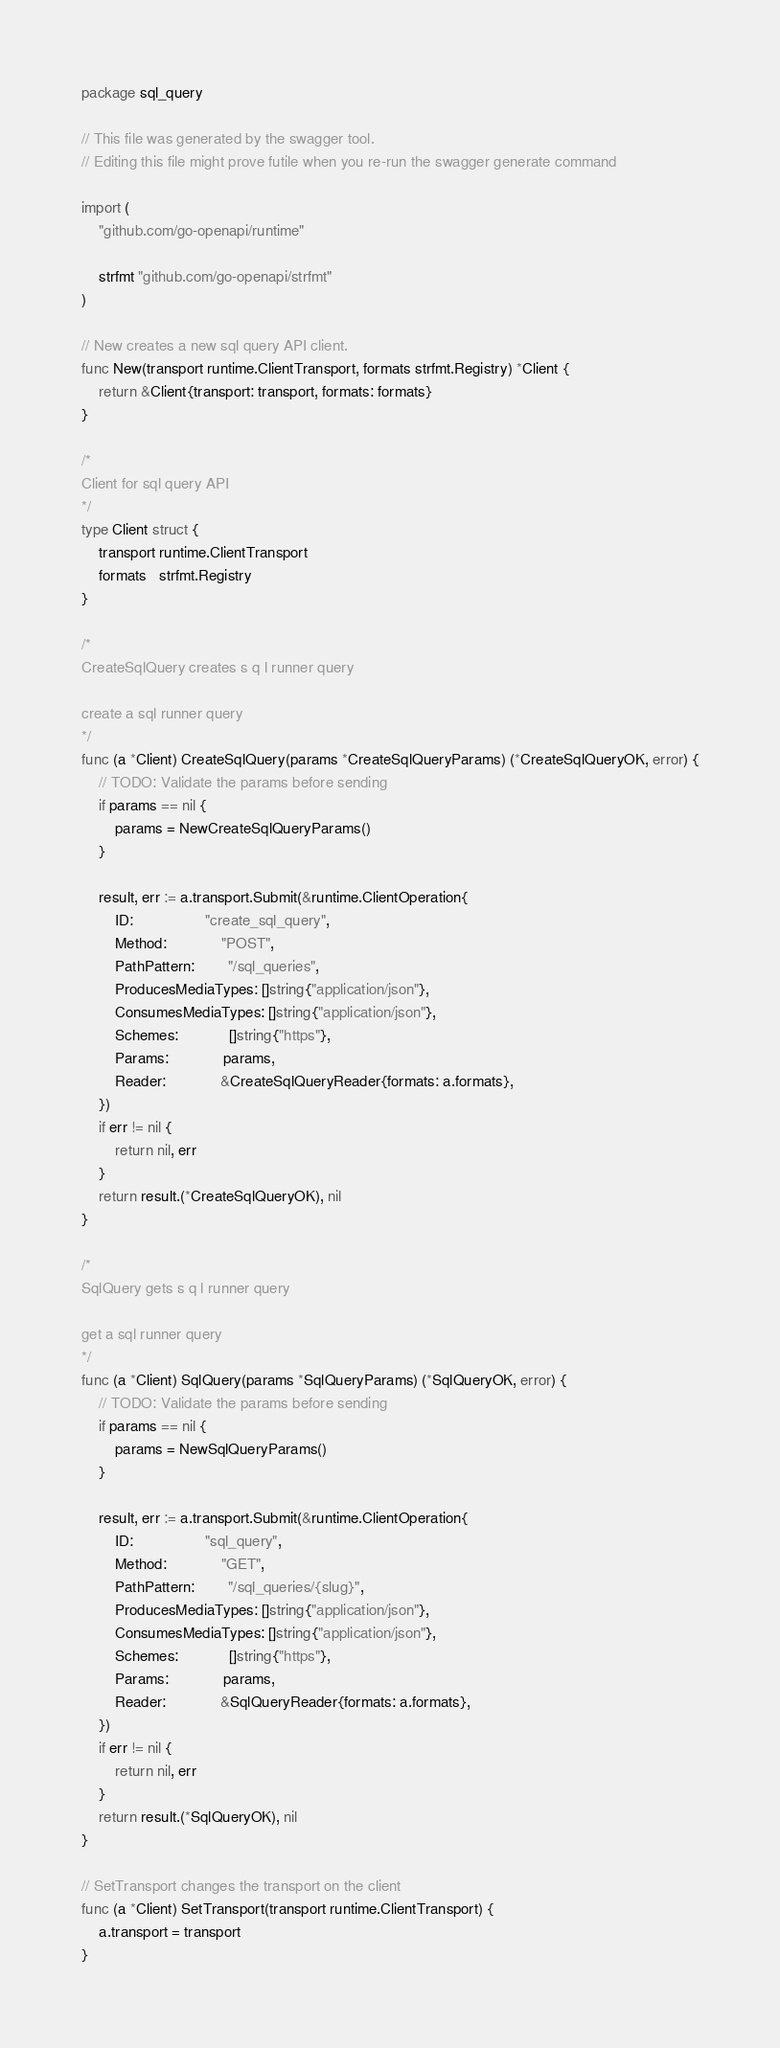<code> <loc_0><loc_0><loc_500><loc_500><_Go_>package sql_query

// This file was generated by the swagger tool.
// Editing this file might prove futile when you re-run the swagger generate command

import (
	"github.com/go-openapi/runtime"

	strfmt "github.com/go-openapi/strfmt"
)

// New creates a new sql query API client.
func New(transport runtime.ClientTransport, formats strfmt.Registry) *Client {
	return &Client{transport: transport, formats: formats}
}

/*
Client for sql query API
*/
type Client struct {
	transport runtime.ClientTransport
	formats   strfmt.Registry
}

/*
CreateSqlQuery creates s q l runner query

create a sql runner query
*/
func (a *Client) CreateSqlQuery(params *CreateSqlQueryParams) (*CreateSqlQueryOK, error) {
	// TODO: Validate the params before sending
	if params == nil {
		params = NewCreateSqlQueryParams()
	}

	result, err := a.transport.Submit(&runtime.ClientOperation{
		ID:                 "create_sql_query",
		Method:             "POST",
		PathPattern:        "/sql_queries",
		ProducesMediaTypes: []string{"application/json"},
		ConsumesMediaTypes: []string{"application/json"},
		Schemes:            []string{"https"},
		Params:             params,
		Reader:             &CreateSqlQueryReader{formats: a.formats},
	})
	if err != nil {
		return nil, err
	}
	return result.(*CreateSqlQueryOK), nil
}

/*
SqlQuery gets s q l runner query

get a sql runner query
*/
func (a *Client) SqlQuery(params *SqlQueryParams) (*SqlQueryOK, error) {
	// TODO: Validate the params before sending
	if params == nil {
		params = NewSqlQueryParams()
	}

	result, err := a.transport.Submit(&runtime.ClientOperation{
		ID:                 "sql_query",
		Method:             "GET",
		PathPattern:        "/sql_queries/{slug}",
		ProducesMediaTypes: []string{"application/json"},
		ConsumesMediaTypes: []string{"application/json"},
		Schemes:            []string{"https"},
		Params:             params,
		Reader:             &SqlQueryReader{formats: a.formats},
	})
	if err != nil {
		return nil, err
	}
	return result.(*SqlQueryOK), nil
}

// SetTransport changes the transport on the client
func (a *Client) SetTransport(transport runtime.ClientTransport) {
	a.transport = transport
}
</code> 